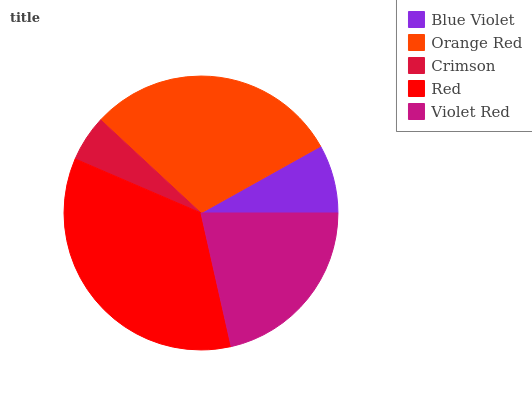Is Crimson the minimum?
Answer yes or no. Yes. Is Red the maximum?
Answer yes or no. Yes. Is Orange Red the minimum?
Answer yes or no. No. Is Orange Red the maximum?
Answer yes or no. No. Is Orange Red greater than Blue Violet?
Answer yes or no. Yes. Is Blue Violet less than Orange Red?
Answer yes or no. Yes. Is Blue Violet greater than Orange Red?
Answer yes or no. No. Is Orange Red less than Blue Violet?
Answer yes or no. No. Is Violet Red the high median?
Answer yes or no. Yes. Is Violet Red the low median?
Answer yes or no. Yes. Is Crimson the high median?
Answer yes or no. No. Is Red the low median?
Answer yes or no. No. 